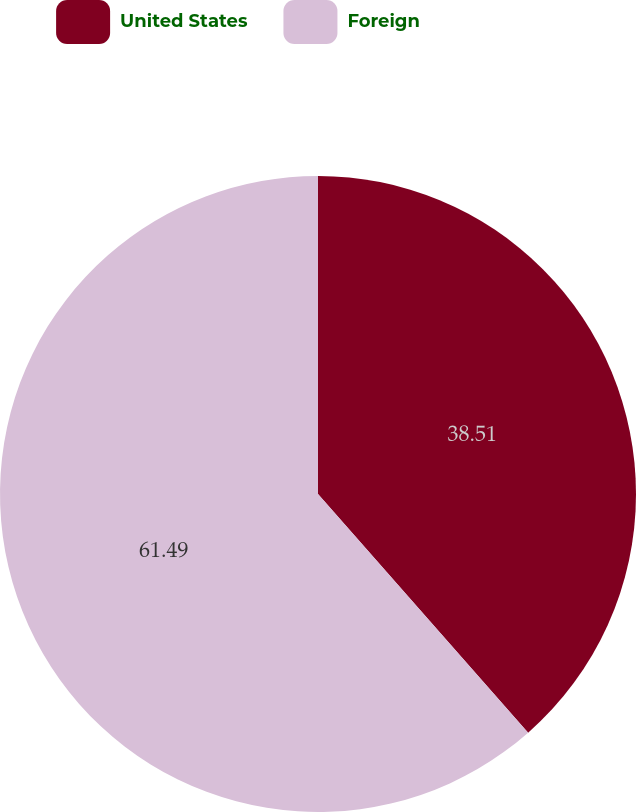Convert chart. <chart><loc_0><loc_0><loc_500><loc_500><pie_chart><fcel>United States<fcel>Foreign<nl><fcel>38.51%<fcel>61.49%<nl></chart> 